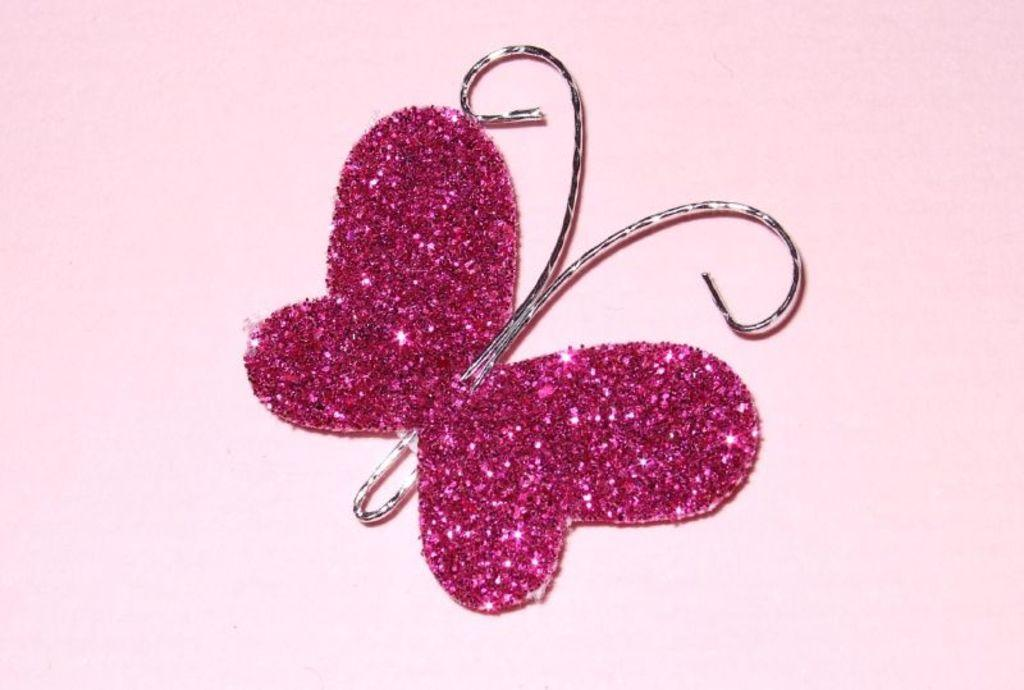What shape is the pin in the image? The pin in the image is butterfly-shaped. What color is the butterfly-shaped pin? The pin is pink in color. Where can the lock be found in the image? There is no lock present in the image. How many ducks are visible in the image? There are no ducks present in the image. 